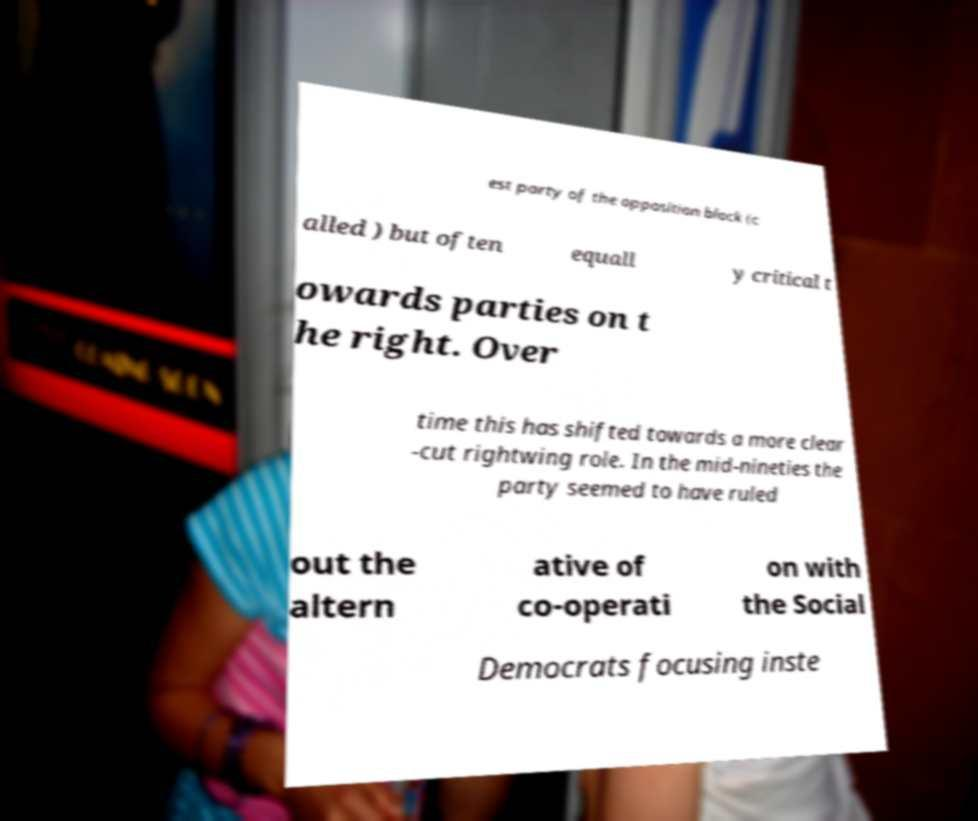Can you read and provide the text displayed in the image?This photo seems to have some interesting text. Can you extract and type it out for me? est party of the opposition block (c alled ) but often equall y critical t owards parties on t he right. Over time this has shifted towards a more clear -cut rightwing role. In the mid-nineties the party seemed to have ruled out the altern ative of co-operati on with the Social Democrats focusing inste 